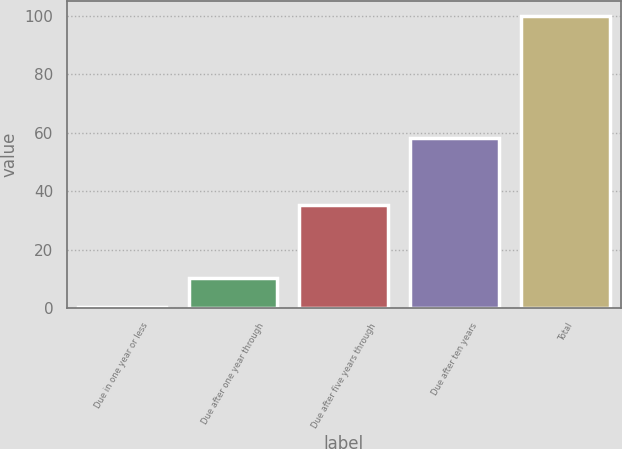Convert chart. <chart><loc_0><loc_0><loc_500><loc_500><bar_chart><fcel>Due in one year or less<fcel>Due after one year through<fcel>Due after five years through<fcel>Due after ten years<fcel>Total<nl><fcel>0.4<fcel>10.36<fcel>35.2<fcel>58.3<fcel>100<nl></chart> 